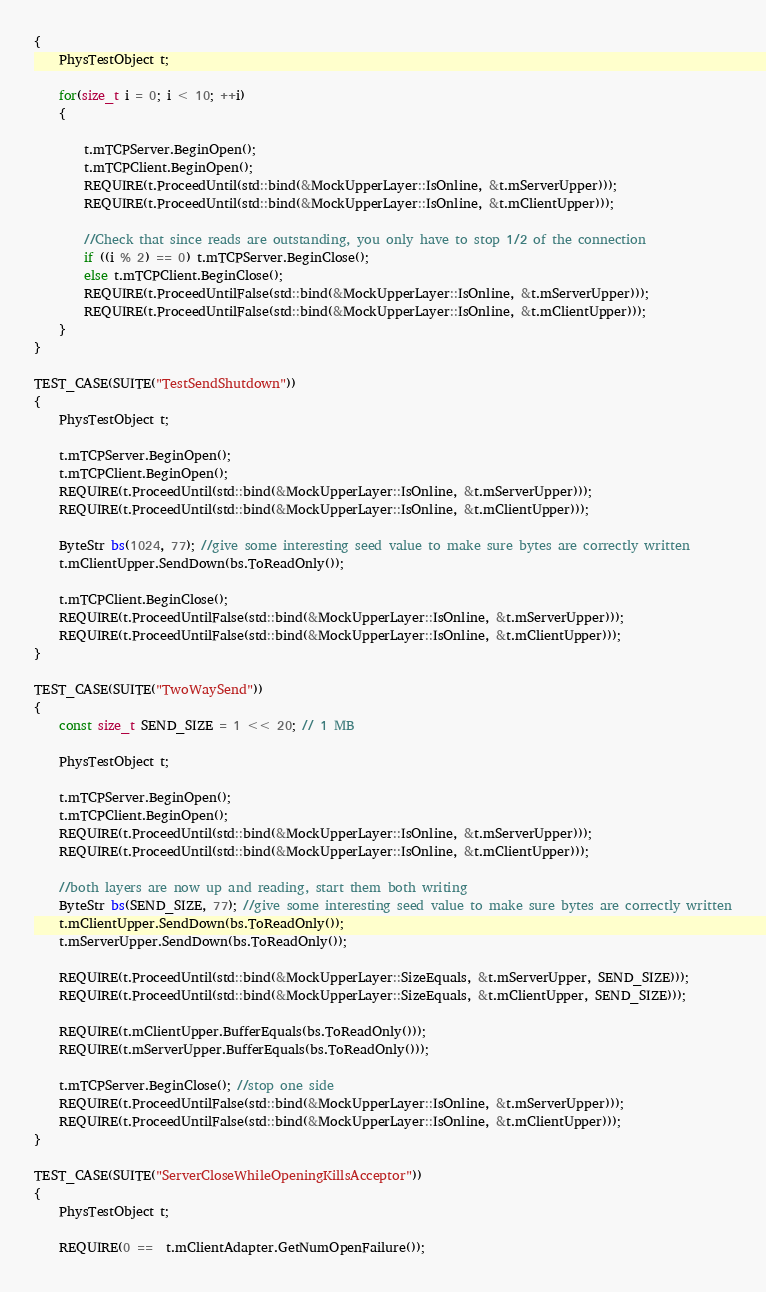Convert code to text. <code><loc_0><loc_0><loc_500><loc_500><_C++_>{
	PhysTestObject t;

	for(size_t i = 0; i < 10; ++i)
	{

		t.mTCPServer.BeginOpen();
		t.mTCPClient.BeginOpen();
		REQUIRE(t.ProceedUntil(std::bind(&MockUpperLayer::IsOnline, &t.mServerUpper)));
		REQUIRE(t.ProceedUntil(std::bind(&MockUpperLayer::IsOnline, &t.mClientUpper)));

		//Check that since reads are outstanding, you only have to stop 1/2 of the connection
		if ((i % 2) == 0) t.mTCPServer.BeginClose();
		else t.mTCPClient.BeginClose();
		REQUIRE(t.ProceedUntilFalse(std::bind(&MockUpperLayer::IsOnline, &t.mServerUpper)));
		REQUIRE(t.ProceedUntilFalse(std::bind(&MockUpperLayer::IsOnline, &t.mClientUpper)));
	}
}

TEST_CASE(SUITE("TestSendShutdown"))
{
	PhysTestObject t;

	t.mTCPServer.BeginOpen();
	t.mTCPClient.BeginOpen();
	REQUIRE(t.ProceedUntil(std::bind(&MockUpperLayer::IsOnline, &t.mServerUpper)));
	REQUIRE(t.ProceedUntil(std::bind(&MockUpperLayer::IsOnline, &t.mClientUpper)));

	ByteStr bs(1024, 77); //give some interesting seed value to make sure bytes are correctly written
	t.mClientUpper.SendDown(bs.ToReadOnly());

	t.mTCPClient.BeginClose();
	REQUIRE(t.ProceedUntilFalse(std::bind(&MockUpperLayer::IsOnline, &t.mServerUpper)));
	REQUIRE(t.ProceedUntilFalse(std::bind(&MockUpperLayer::IsOnline, &t.mClientUpper)));
}

TEST_CASE(SUITE("TwoWaySend"))
{
	const size_t SEND_SIZE = 1 << 20; // 1 MB

	PhysTestObject t;

	t.mTCPServer.BeginOpen();
	t.mTCPClient.BeginOpen();
	REQUIRE(t.ProceedUntil(std::bind(&MockUpperLayer::IsOnline, &t.mServerUpper)));
	REQUIRE(t.ProceedUntil(std::bind(&MockUpperLayer::IsOnline, &t.mClientUpper)));

	//both layers are now up and reading, start them both writing
	ByteStr bs(SEND_SIZE, 77); //give some interesting seed value to make sure bytes are correctly written
	t.mClientUpper.SendDown(bs.ToReadOnly());
	t.mServerUpper.SendDown(bs.ToReadOnly());

	REQUIRE(t.ProceedUntil(std::bind(&MockUpperLayer::SizeEquals, &t.mServerUpper, SEND_SIZE)));
	REQUIRE(t.ProceedUntil(std::bind(&MockUpperLayer::SizeEquals, &t.mClientUpper, SEND_SIZE)));

	REQUIRE(t.mClientUpper.BufferEquals(bs.ToReadOnly()));
	REQUIRE(t.mServerUpper.BufferEquals(bs.ToReadOnly()));

	t.mTCPServer.BeginClose(); //stop one side
	REQUIRE(t.ProceedUntilFalse(std::bind(&MockUpperLayer::IsOnline, &t.mServerUpper)));
	REQUIRE(t.ProceedUntilFalse(std::bind(&MockUpperLayer::IsOnline, &t.mClientUpper)));
}

TEST_CASE(SUITE("ServerCloseWhileOpeningKillsAcceptor"))
{
	PhysTestObject t;

	REQUIRE(0 ==  t.mClientAdapter.GetNumOpenFailure());
</code> 